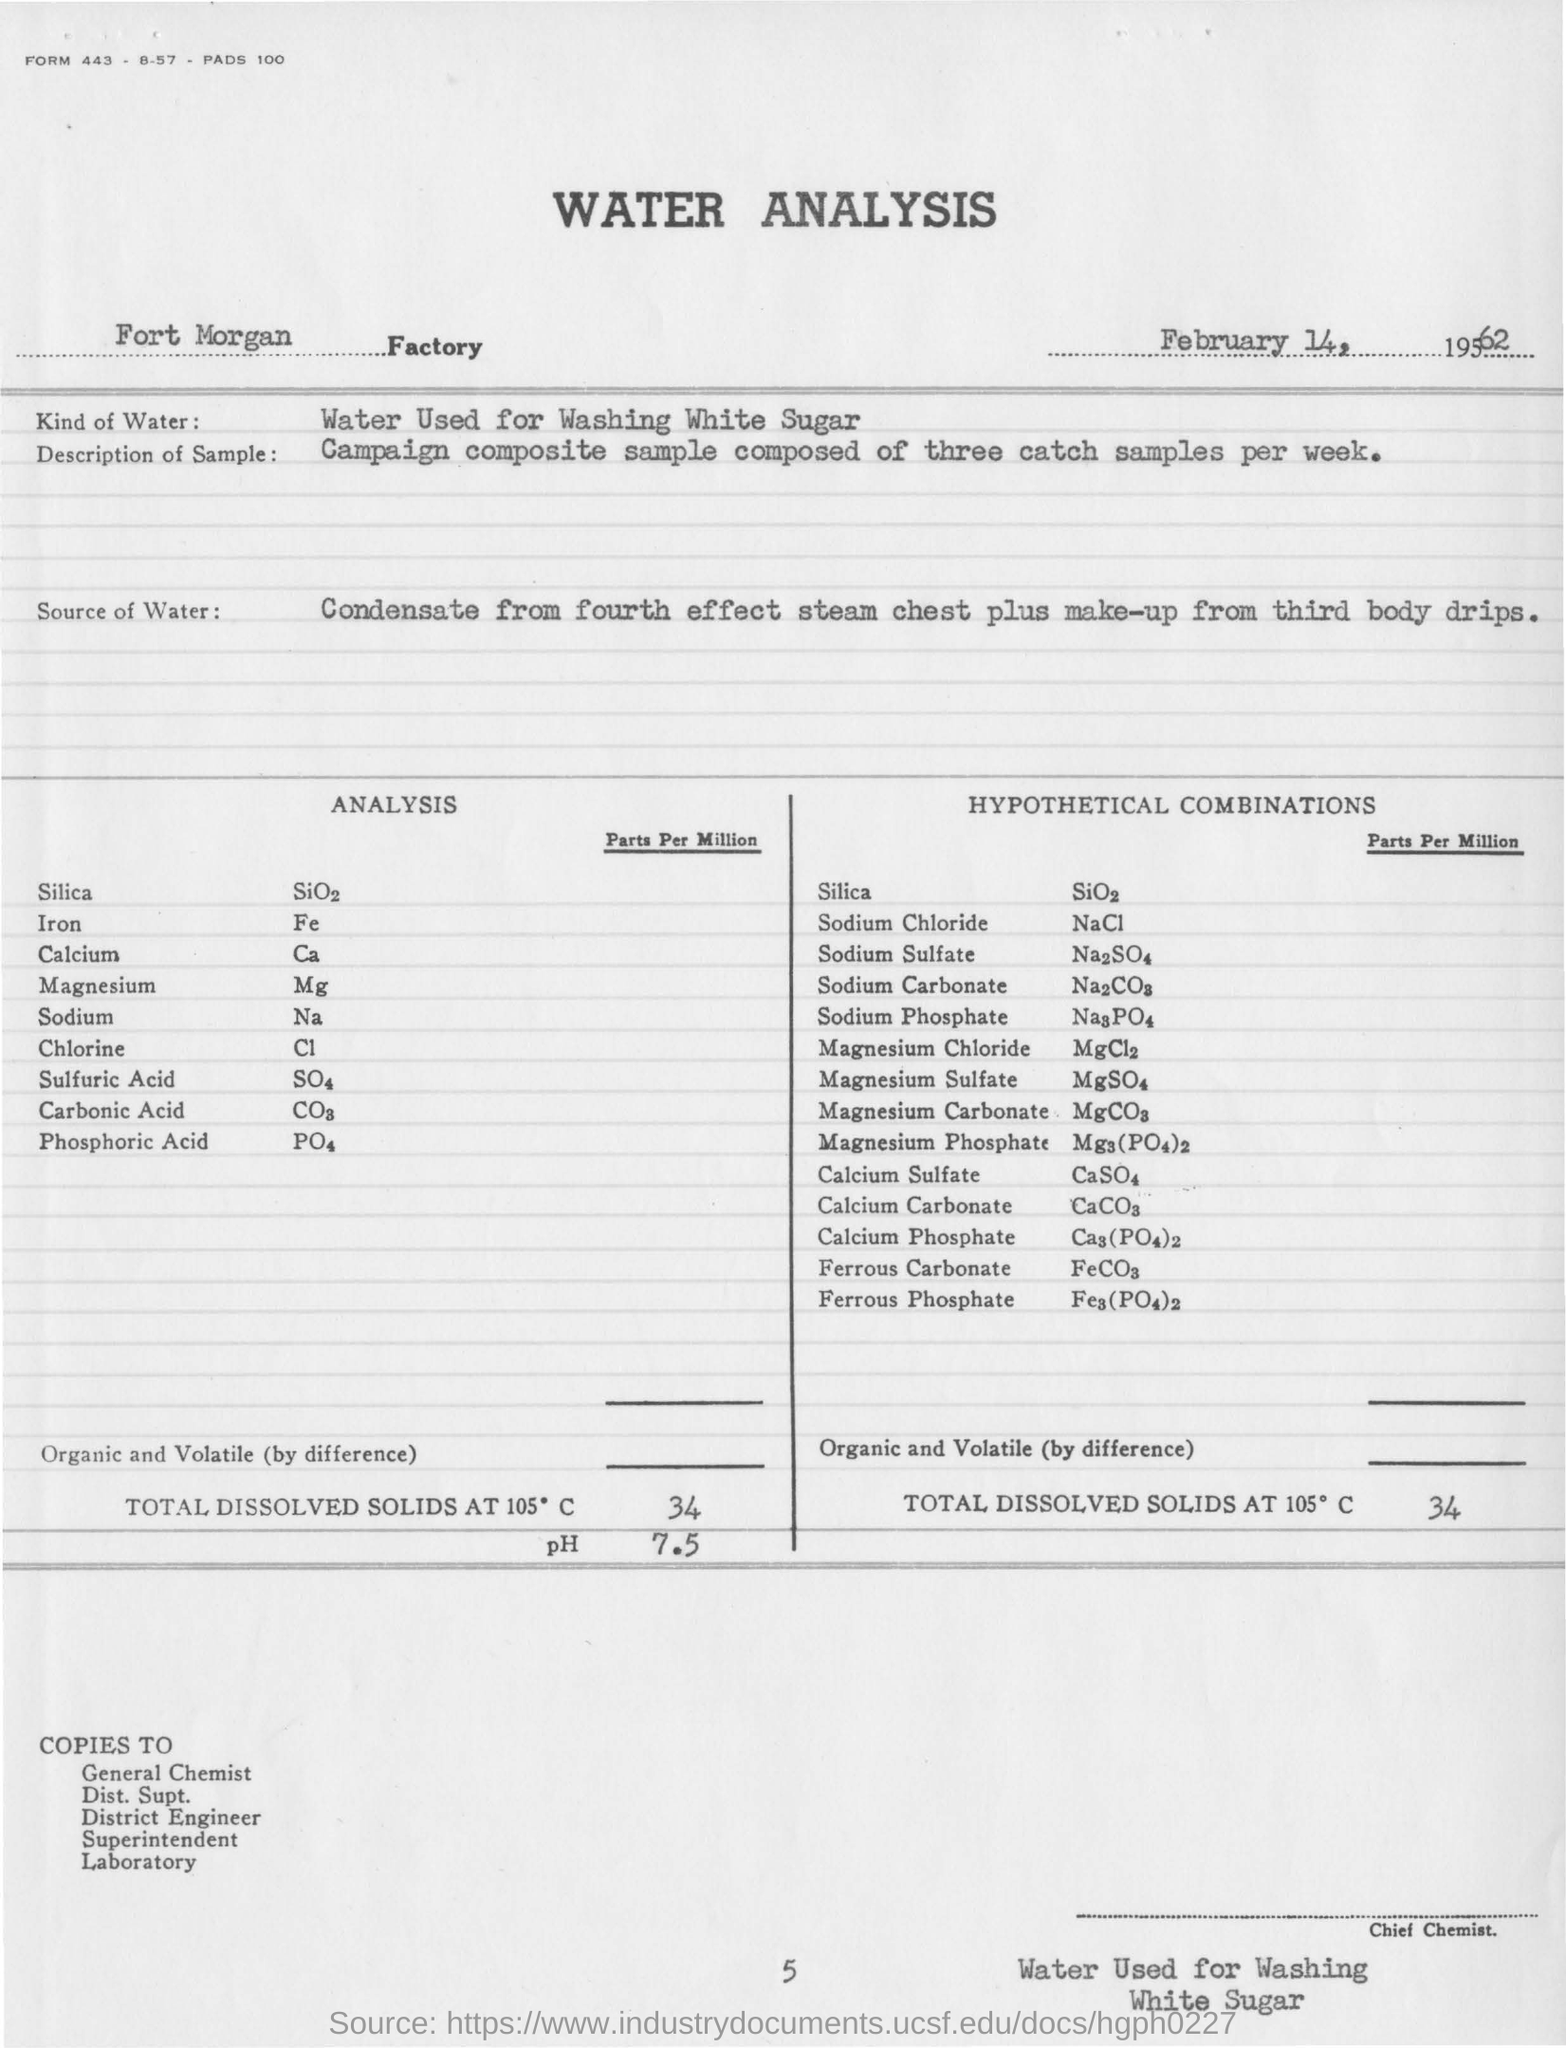On which date water sample test is conducted in fort morgan?
Ensure brevity in your answer.  February 14, 1962. In which factory is  water analysis conducted?
Offer a terse response. Fort morgan factory. What is washed by water at the fort morgan factory?
Your answer should be compact. White sugar. What is the ph value for sample taken from fort morgan?
Offer a terse response. 7.5. What is the total dissolved solids at 105 degree c for the hypothetical combination ?
Your answer should be compact. 34. What is the unit of iron present in water sample?
Offer a terse response. Parts per million. What is the formula for the magnesium?
Provide a succinct answer. Mg. What is the name of chemical compound for na?
Provide a short and direct response. Sodium. 